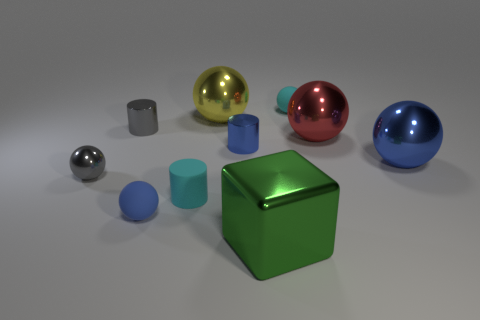Are there more small gray metallic objects than purple matte cylinders?
Offer a very short reply. Yes. There is a big metallic object that is in front of the cyan thing that is left of the large yellow object; is there a big green thing to the left of it?
Your response must be concise. No. What number of other things are there of the same size as the gray metallic cylinder?
Make the answer very short. 5. There is a gray ball; are there any gray cylinders in front of it?
Ensure brevity in your answer.  No. There is a large metal block; is it the same color as the tiny shiny thing that is right of the cyan cylinder?
Offer a terse response. No. What color is the metal thing in front of the small cyan object that is in front of the cyan thing on the right side of the big green metal block?
Provide a short and direct response. Green. Are there any other tiny objects of the same shape as the red thing?
Provide a short and direct response. Yes. There is another shiny cylinder that is the same size as the blue metal cylinder; what is its color?
Offer a terse response. Gray. What material is the cylinder right of the yellow metallic ball?
Give a very brief answer. Metal. There is a tiny matte object that is behind the yellow metal sphere; is its shape the same as the cyan object that is in front of the big red sphere?
Your answer should be very brief. No. 